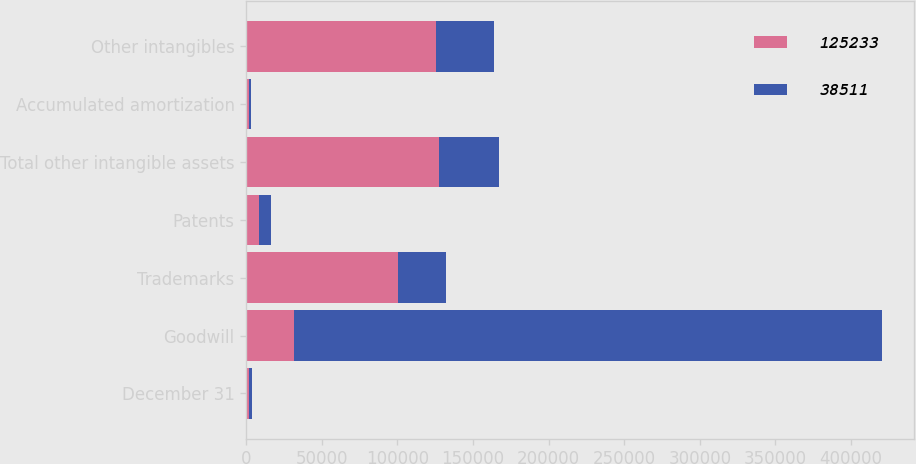Convert chart to OTSL. <chart><loc_0><loc_0><loc_500><loc_500><stacked_bar_chart><ecel><fcel>December 31<fcel>Goodwill<fcel>Trademarks<fcel>Patents<fcel>Total other intangible assets<fcel>Accumulated amortization<fcel>Other intangibles<nl><fcel>125233<fcel>2004<fcel>31593<fcel>100335<fcel>8317<fcel>127219<fcel>1986<fcel>125233<nl><fcel>38511<fcel>2003<fcel>388960<fcel>31593<fcel>8317<fcel>39910<fcel>1399<fcel>38511<nl></chart> 